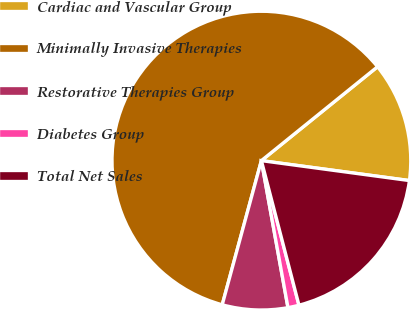Convert chart. <chart><loc_0><loc_0><loc_500><loc_500><pie_chart><fcel>Cardiac and Vascular Group<fcel>Minimally Invasive Therapies<fcel>Restorative Therapies Group<fcel>Diabetes Group<fcel>Total Net Sales<nl><fcel>12.95%<fcel>59.96%<fcel>7.07%<fcel>1.2%<fcel>18.82%<nl></chart> 